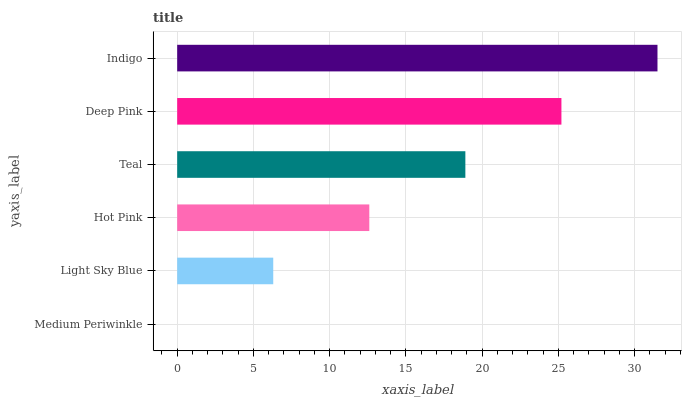Is Medium Periwinkle the minimum?
Answer yes or no. Yes. Is Indigo the maximum?
Answer yes or no. Yes. Is Light Sky Blue the minimum?
Answer yes or no. No. Is Light Sky Blue the maximum?
Answer yes or no. No. Is Light Sky Blue greater than Medium Periwinkle?
Answer yes or no. Yes. Is Medium Periwinkle less than Light Sky Blue?
Answer yes or no. Yes. Is Medium Periwinkle greater than Light Sky Blue?
Answer yes or no. No. Is Light Sky Blue less than Medium Periwinkle?
Answer yes or no. No. Is Teal the high median?
Answer yes or no. Yes. Is Hot Pink the low median?
Answer yes or no. Yes. Is Hot Pink the high median?
Answer yes or no. No. Is Medium Periwinkle the low median?
Answer yes or no. No. 